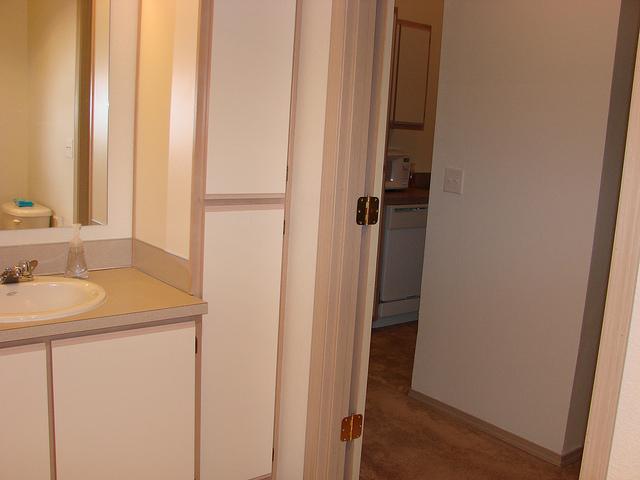What color is the countertop?
Answer briefly. Beige. Is the door open?
Answer briefly. Yes. What kind of room is this?
Answer briefly. Bathroom. What color appliances do they own?
Answer briefly. White. Is someone living in this home?
Concise answer only. Yes. How many mirrors are in this photo?
Concise answer only. 1. Is a person visible in the mirror?
Answer briefly. No. 